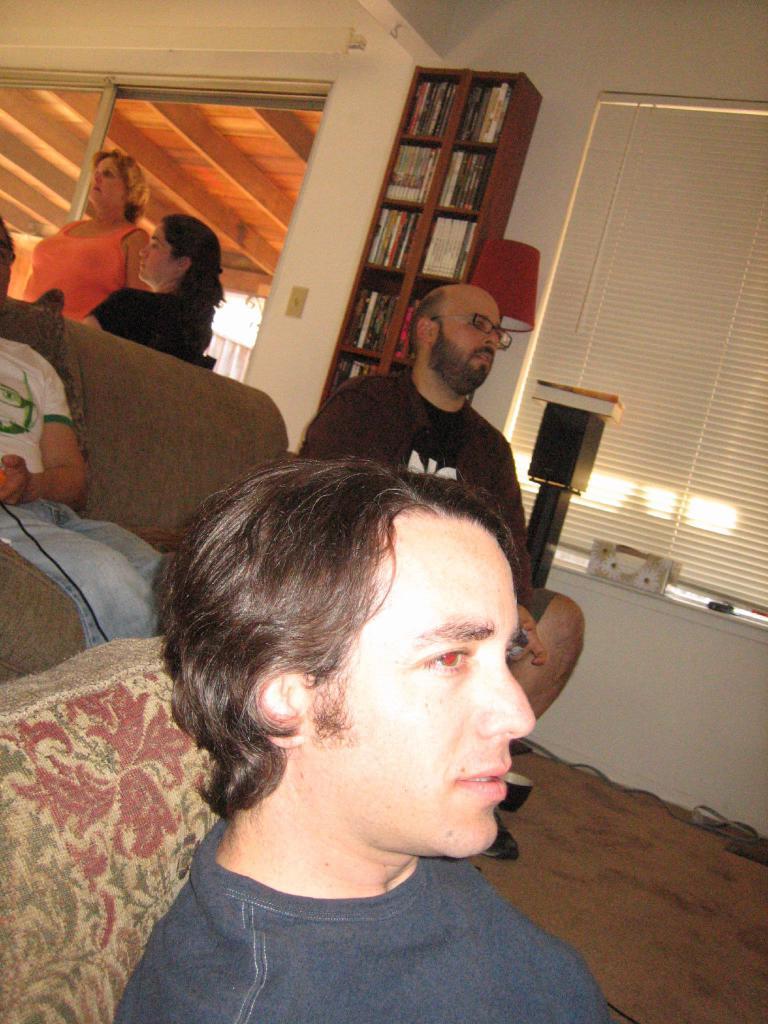Please provide a concise description of this image. At the bottom of the picture, the man in blue T-shirt is lying on the floor. Behind him, we see a pillow. Behind him, the man in white T-shirt is sitting on the sofa. Beside him, the man in black T-shirt is sitting on the chair. Behind them, we see two women talking to each other. Behind them, we see a window and a white wall. Beside that, we see a rack in which many books are placed. Beside that, there is a lamp and the window blind. This picture is clicked inside the room. 